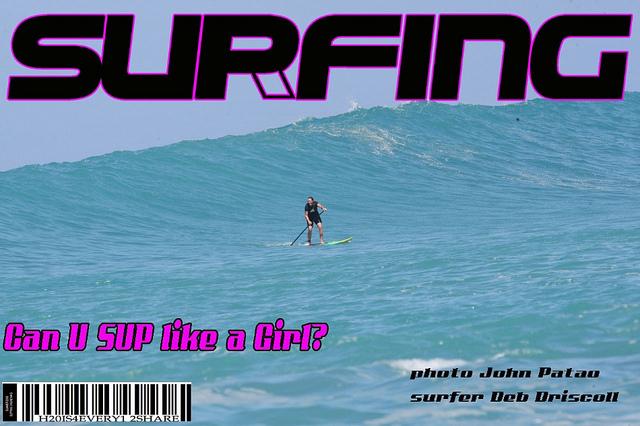What is this girl doing in the water?
Answer briefly. Surfing. Is there a barcode on the picture?
Give a very brief answer. Yes. What colors are the letters SUP?
Give a very brief answer. Black. 